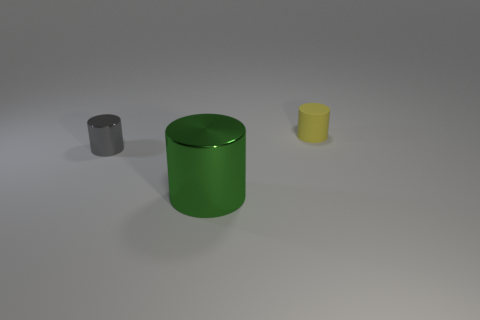There is a tiny cylinder to the right of the small cylinder that is in front of the object right of the big green metal object; what is its material?
Your response must be concise. Rubber. How many other things are there of the same material as the green cylinder?
Your response must be concise. 1. There is a tiny cylinder that is in front of the tiny rubber object; how many big metallic cylinders are to the left of it?
Your answer should be compact. 0. What number of balls are either large green objects or gray shiny objects?
Offer a very short reply. 0. There is a object that is to the right of the gray cylinder and on the left side of the yellow thing; what color is it?
Keep it short and to the point. Green. Are there any other things that are the same color as the small matte cylinder?
Keep it short and to the point. No. What is the color of the tiny thing that is to the left of the thing behind the small gray metallic cylinder?
Offer a very short reply. Gray. Is the size of the yellow rubber cylinder the same as the green shiny cylinder?
Provide a short and direct response. No. Is the material of the cylinder in front of the tiny gray shiny thing the same as the object behind the tiny gray thing?
Your answer should be very brief. No. There is a tiny thing left of the object that is in front of the tiny thing that is in front of the rubber cylinder; what shape is it?
Your answer should be very brief. Cylinder. 